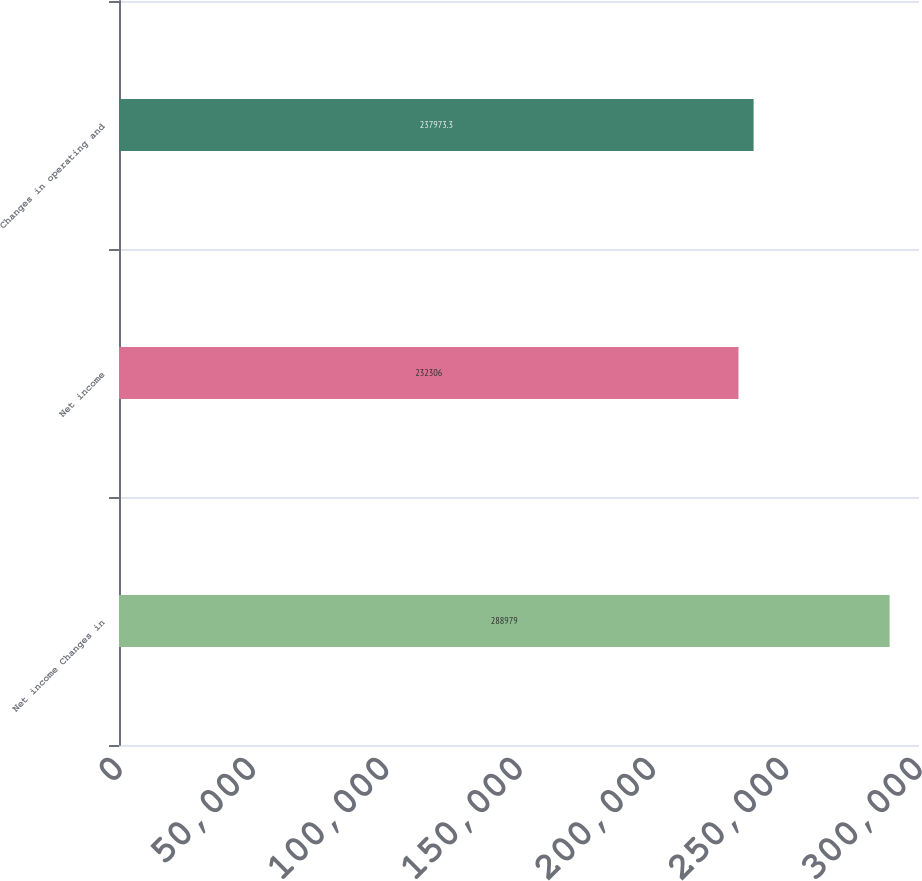<chart> <loc_0><loc_0><loc_500><loc_500><bar_chart><fcel>Net income Changes in<fcel>Net income<fcel>Changes in operating and<nl><fcel>288979<fcel>232306<fcel>237973<nl></chart> 